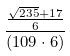<formula> <loc_0><loc_0><loc_500><loc_500>\frac { \frac { \sqrt { 2 3 5 } + 1 7 } { 6 } } { ( 1 0 9 \cdot 6 ) }</formula> 